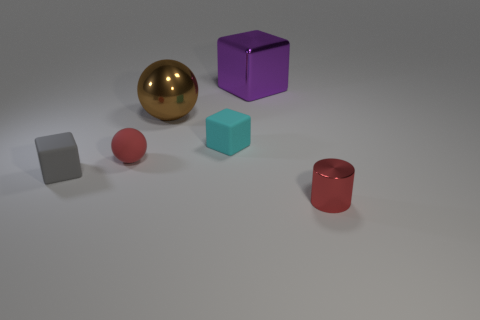There is a red object to the left of the big purple object; what is it made of?
Your response must be concise. Rubber. How many objects are red things on the left side of the purple metal block or large brown shiny things?
Ensure brevity in your answer.  2. What number of other objects are there of the same shape as the small red rubber object?
Provide a short and direct response. 1. Does the thing on the left side of the small red matte object have the same shape as the small cyan object?
Your answer should be compact. Yes. There is a large metallic sphere; are there any tiny rubber cubes right of it?
Keep it short and to the point. Yes. What number of large things are red cylinders or green rubber spheres?
Offer a terse response. 0. Is the material of the cyan cube the same as the small gray cube?
Ensure brevity in your answer.  Yes. Is there a small matte object of the same color as the matte ball?
Ensure brevity in your answer.  No. There is a red sphere that is the same material as the gray thing; what size is it?
Keep it short and to the point. Small. The tiny red thing on the left side of the small thing that is behind the red thing behind the red shiny cylinder is what shape?
Your answer should be compact. Sphere. 